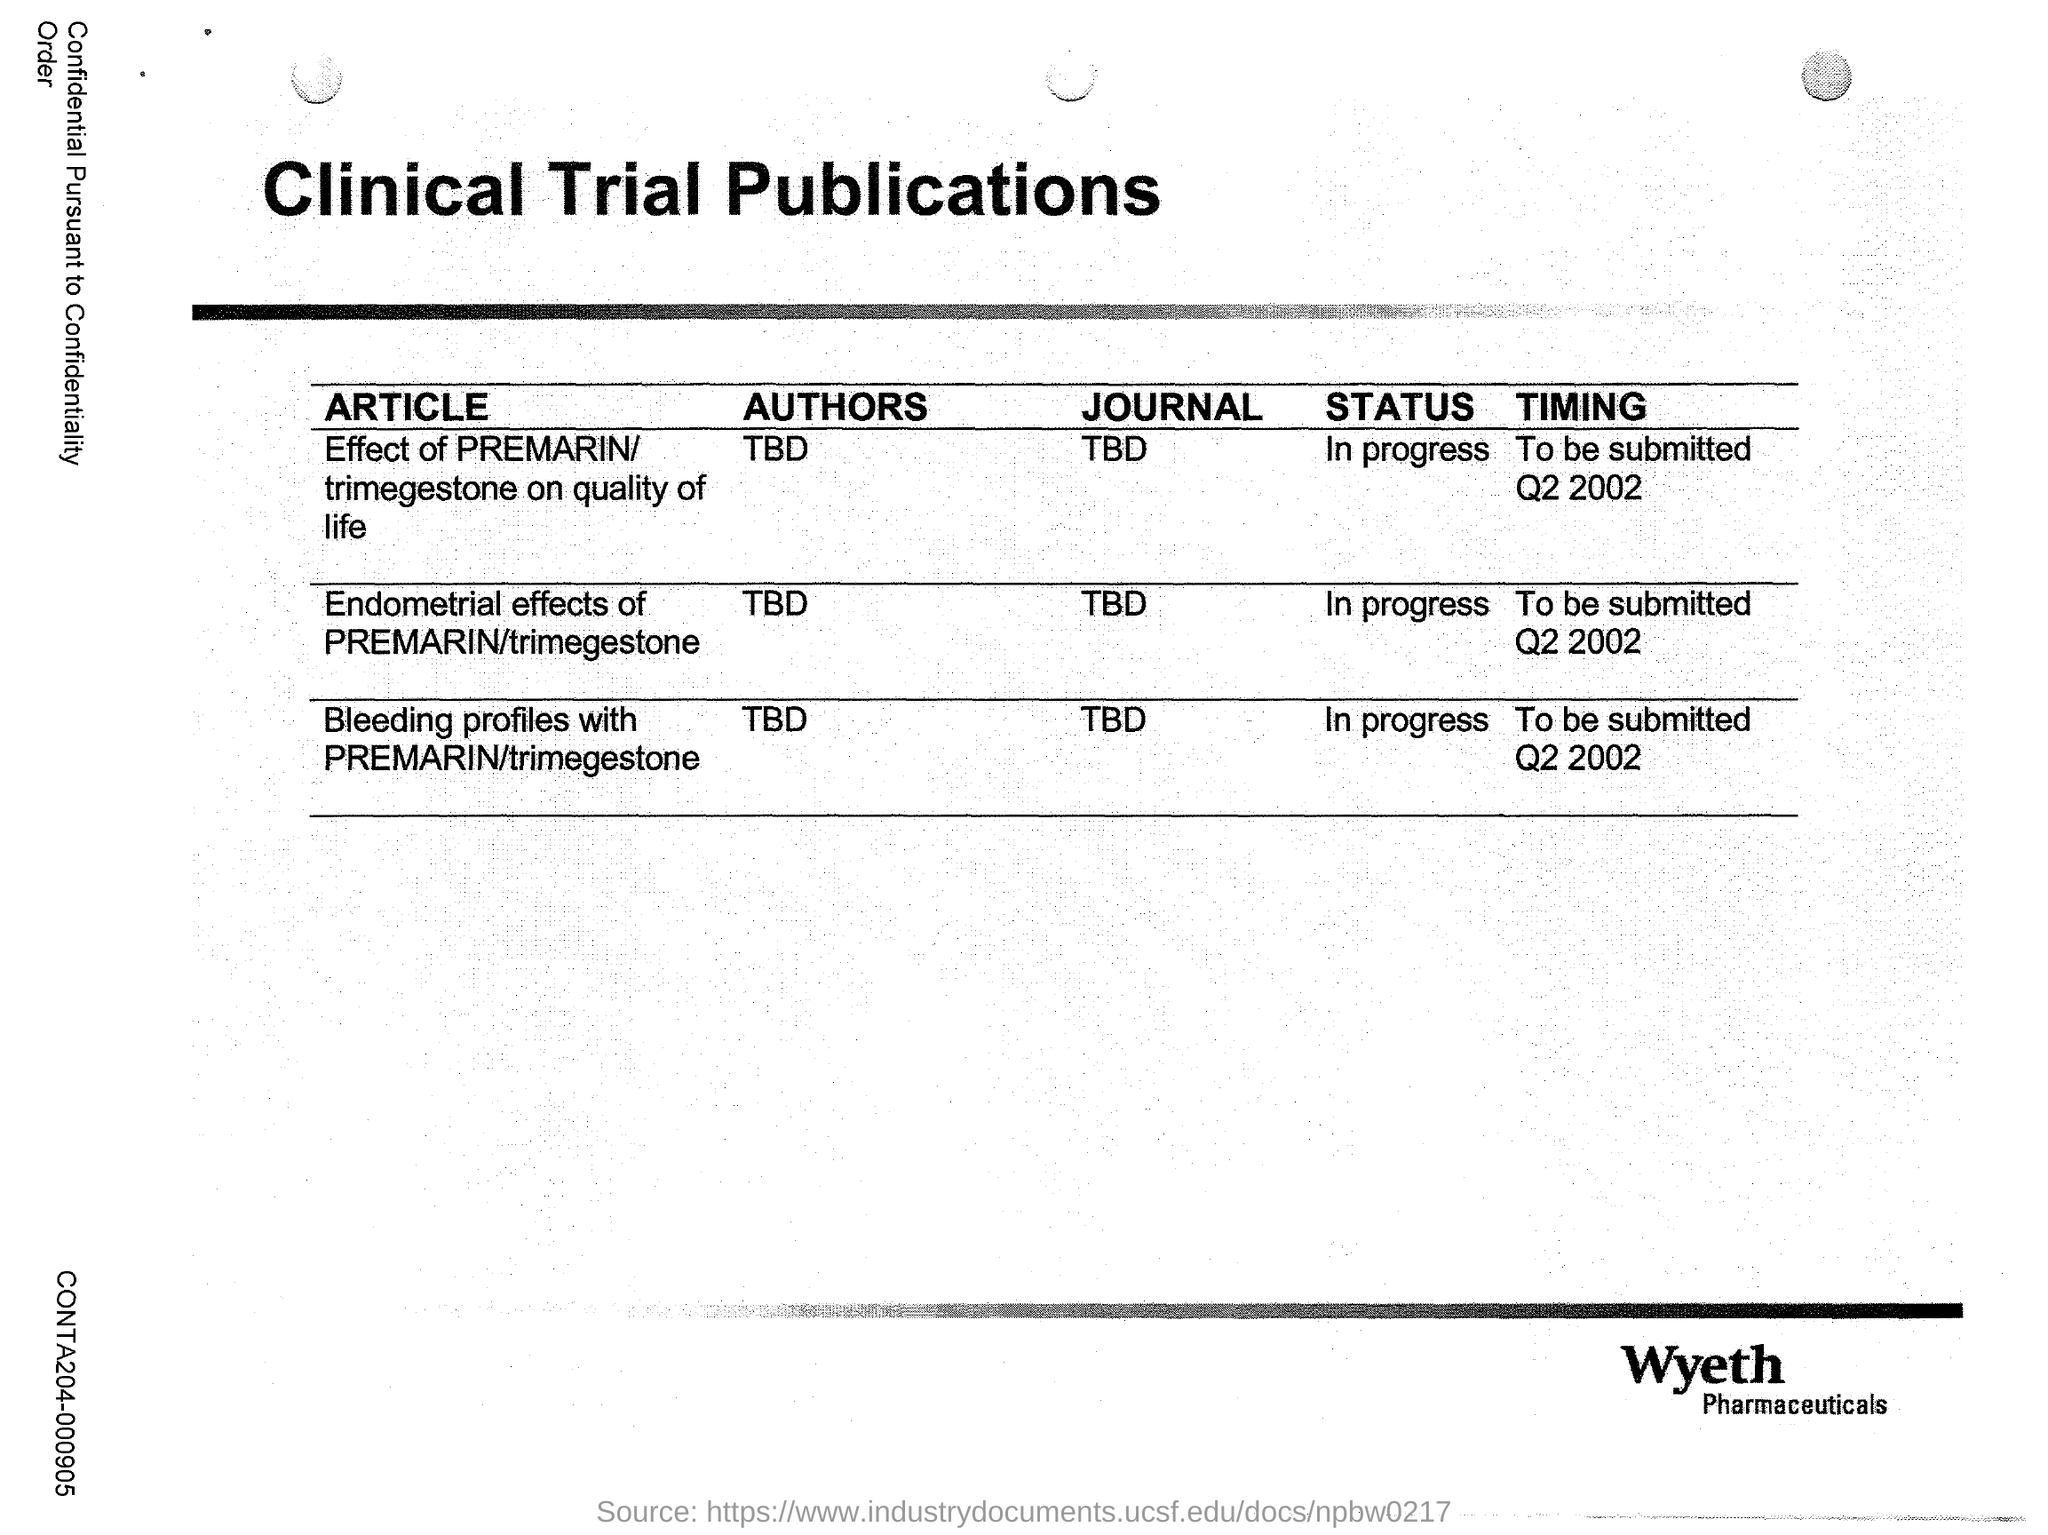What is the title of this document?
Offer a very short reply. Clinical Trial Publications. What is the status of the Article titled 'Endometrial effects of PREMARIN/trimegestone'?
Make the answer very short. In progress. Who is the author of the article titled 'Endometrial effects of PREMARIN/trimegestone'?
Your answer should be very brief. TBD. Which pharmaceutical's clinical trial publications is this?
Your answer should be compact. Wyeth. 